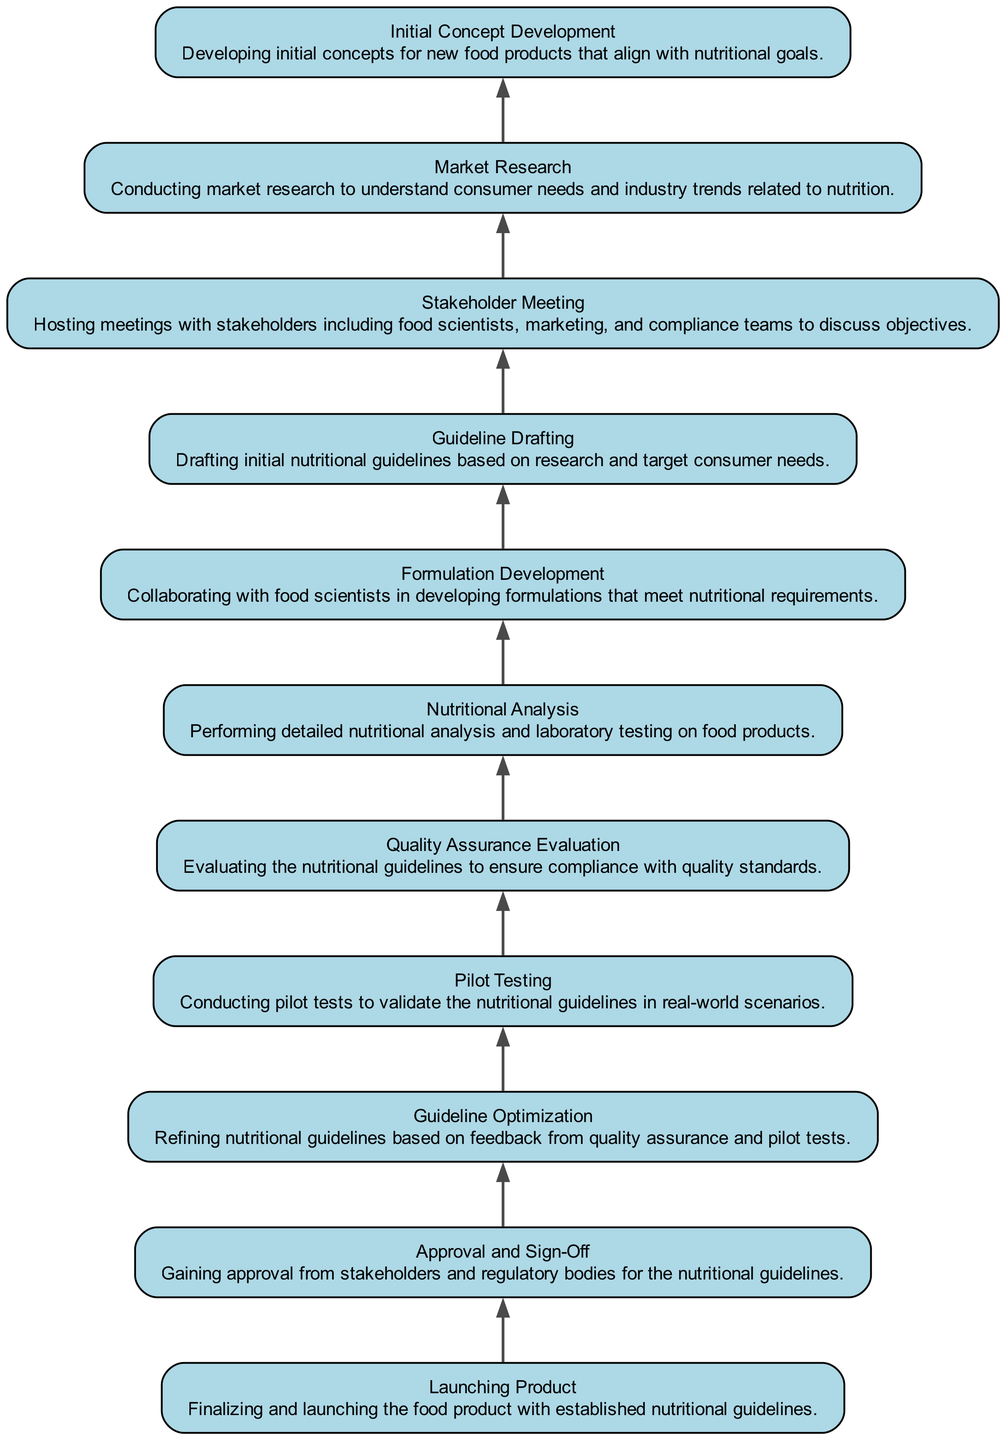What is the final stage in the development process? The final stage in the development process, identified at the top of the flow chart, is "Launching Product," which denotes the completion of the project with the established nutritional guidelines ready for market release.
Answer: Launching Product How many total nodes are present in the diagram? By counting the unique stages represented in the flow chart, it is determined that there are 10 nodes present. These stages encompass various phases of developing nutritional guidelines in collaboration with food scientists.
Answer: 10 What comes directly before the "Pilot Testing" phase? Referring to the flow of the diagram, the phase that comes directly before "Pilot Testing" is "Guideline Optimization." This order indicates that guidelines are refined based on feedback prior to testing.
Answer: Guideline Optimization Which phase includes stakeholder engagement? The phase that includes stakeholder engagement as indicated in the chart is "Stakeholder Meeting," where various teams gather to discuss the objectives of the project.
Answer: Stakeholder Meeting What is the purpose of the "Market Research" phase? "Market Research" serves to gather information on consumer needs and industry trends related to nutrition before further developments are made in the product line.
Answer: Understanding consumer needs What is the relationship between "Nutritional Analysis" and "Formulation Development"? "Nutritional Analysis" occurs after "Formulation Development" as indicated in the diagram, suggesting that formulations created are subjected to detailed nutritional scrutiny to ensure they meet requirements.
Answer: Nutritional Analysis happens after Formulation Development What is the first step in developing nutritional guidelines? The initial step in developing nutritional guidelines highlighted in the flow chart is "Initial Concept Development," which sets the stage for subsequent phases by generating initial product concepts aligned with nutritional goals.
Answer: Initial Concept Development How does "Approval and Sign-Off" relate to "Guideline Optimization"? "Approval and Sign-Off" follows "Guideline Optimization" in the flow, indicating that final approval from stakeholders and regulatory bodies is necessary after refining the nutritional guidelines.
Answer: Approval and Sign-Off follows Guideline Optimization 